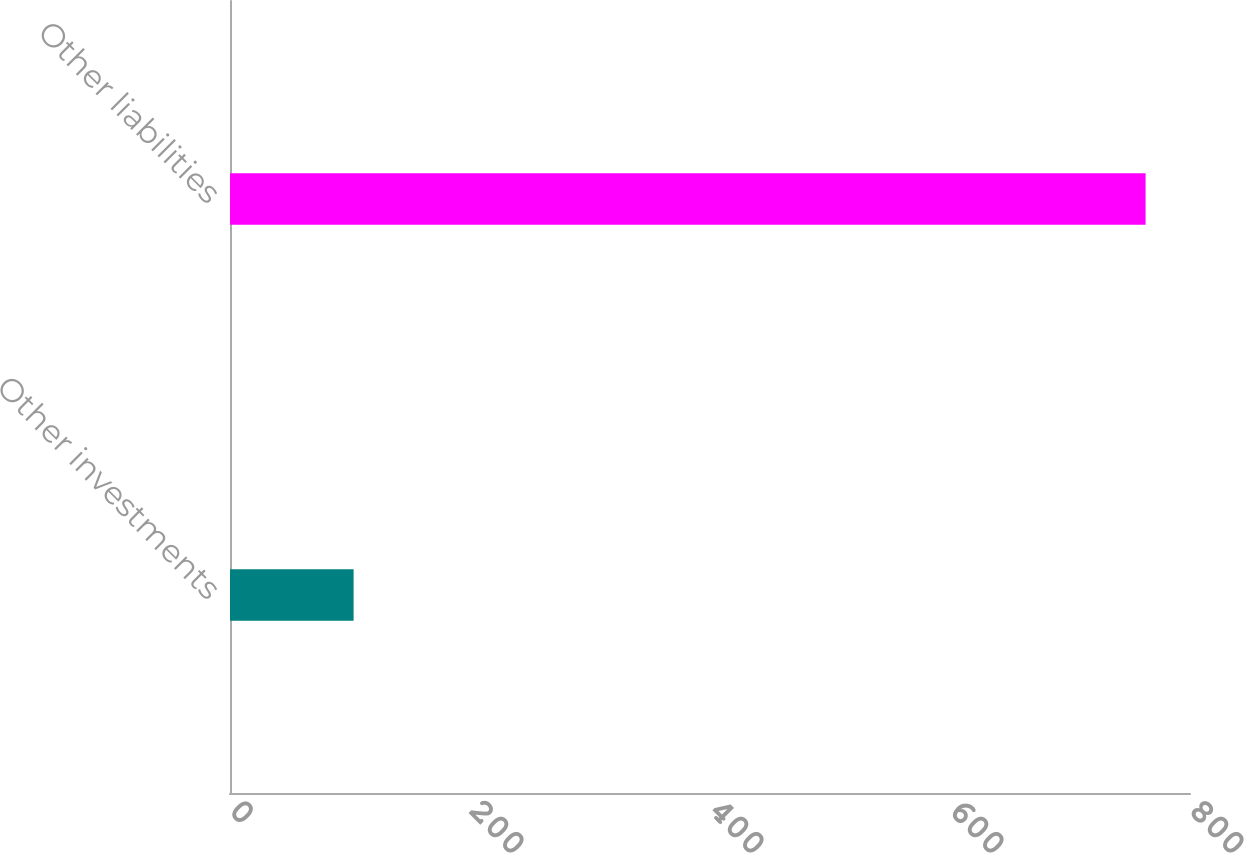Convert chart. <chart><loc_0><loc_0><loc_500><loc_500><bar_chart><fcel>Other investments<fcel>Other liabilities<nl><fcel>103<fcel>763<nl></chart> 